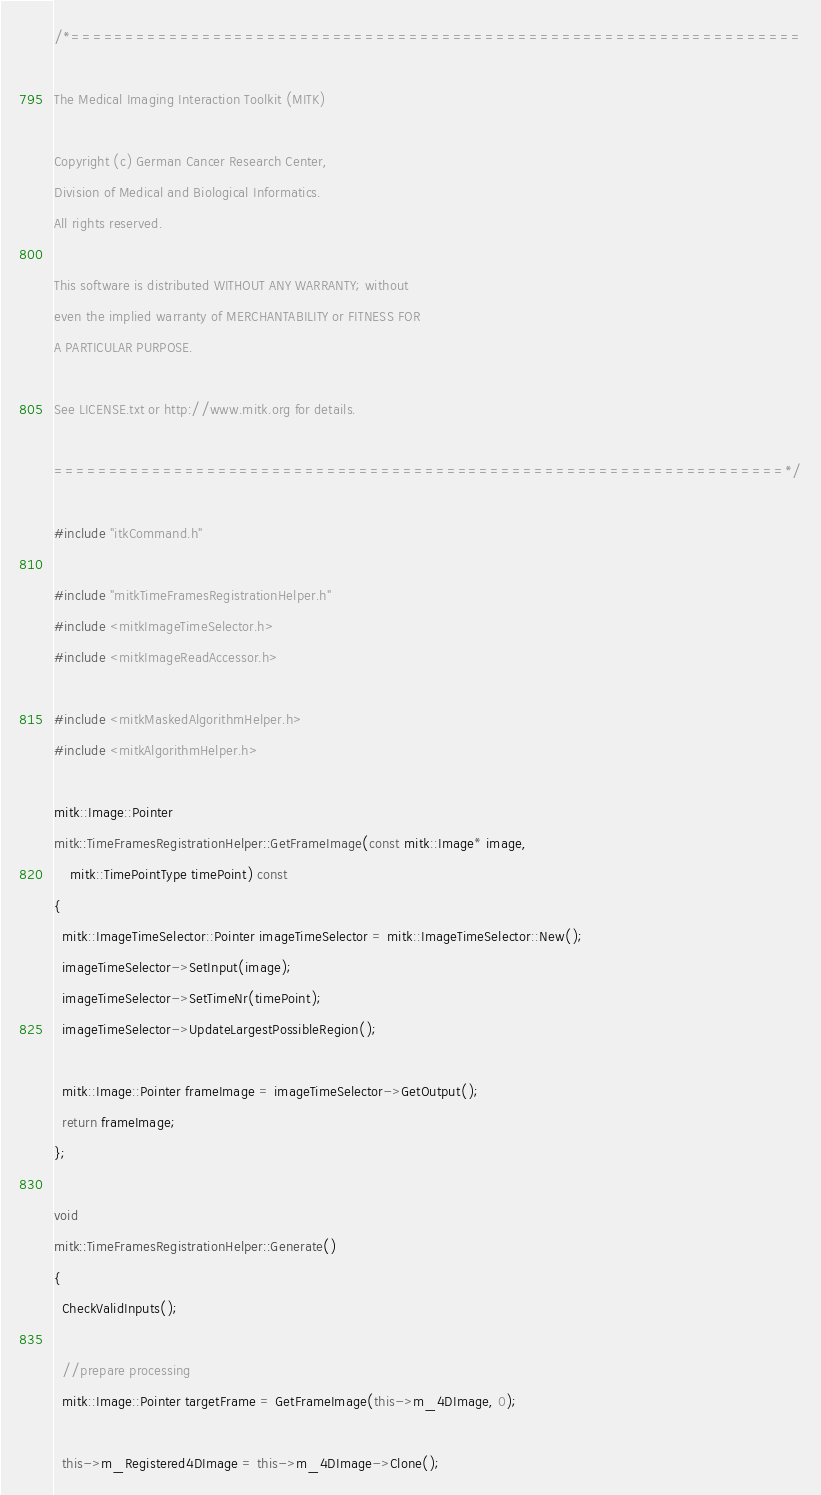<code> <loc_0><loc_0><loc_500><loc_500><_C++_>/*===================================================================

The Medical Imaging Interaction Toolkit (MITK)

Copyright (c) German Cancer Research Center,
Division of Medical and Biological Informatics.
All rights reserved.

This software is distributed WITHOUT ANY WARRANTY; without
even the implied warranty of MERCHANTABILITY or FITNESS FOR
A PARTICULAR PURPOSE.

See LICENSE.txt or http://www.mitk.org for details.

===================================================================*/

#include "itkCommand.h"

#include "mitkTimeFramesRegistrationHelper.h"
#include <mitkImageTimeSelector.h>
#include <mitkImageReadAccessor.h>

#include <mitkMaskedAlgorithmHelper.h>
#include <mitkAlgorithmHelper.h>

mitk::Image::Pointer
mitk::TimeFramesRegistrationHelper::GetFrameImage(const mitk::Image* image,
    mitk::TimePointType timePoint) const
{
  mitk::ImageTimeSelector::Pointer imageTimeSelector = mitk::ImageTimeSelector::New();
  imageTimeSelector->SetInput(image);
  imageTimeSelector->SetTimeNr(timePoint);
  imageTimeSelector->UpdateLargestPossibleRegion();

  mitk::Image::Pointer frameImage = imageTimeSelector->GetOutput();
  return frameImage;
};

void
mitk::TimeFramesRegistrationHelper::Generate()
{
  CheckValidInputs();

  //prepare processing
  mitk::Image::Pointer targetFrame = GetFrameImage(this->m_4DImage, 0);

  this->m_Registered4DImage = this->m_4DImage->Clone();
</code> 